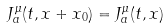<formula> <loc_0><loc_0><loc_500><loc_500>J ^ { \mu } _ { a } ( t , x + x _ { 0 } ) = J ^ { \mu } _ { a } ( t , x )</formula> 